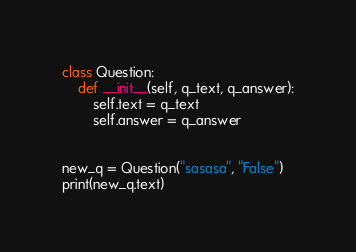Convert code to text. <code><loc_0><loc_0><loc_500><loc_500><_Python_>class Question:
    def __init__(self, q_text, q_answer):
        self.text = q_text
        self.answer = q_answer


new_q = Question("sasasa", "False")
print(new_q.text)
</code> 